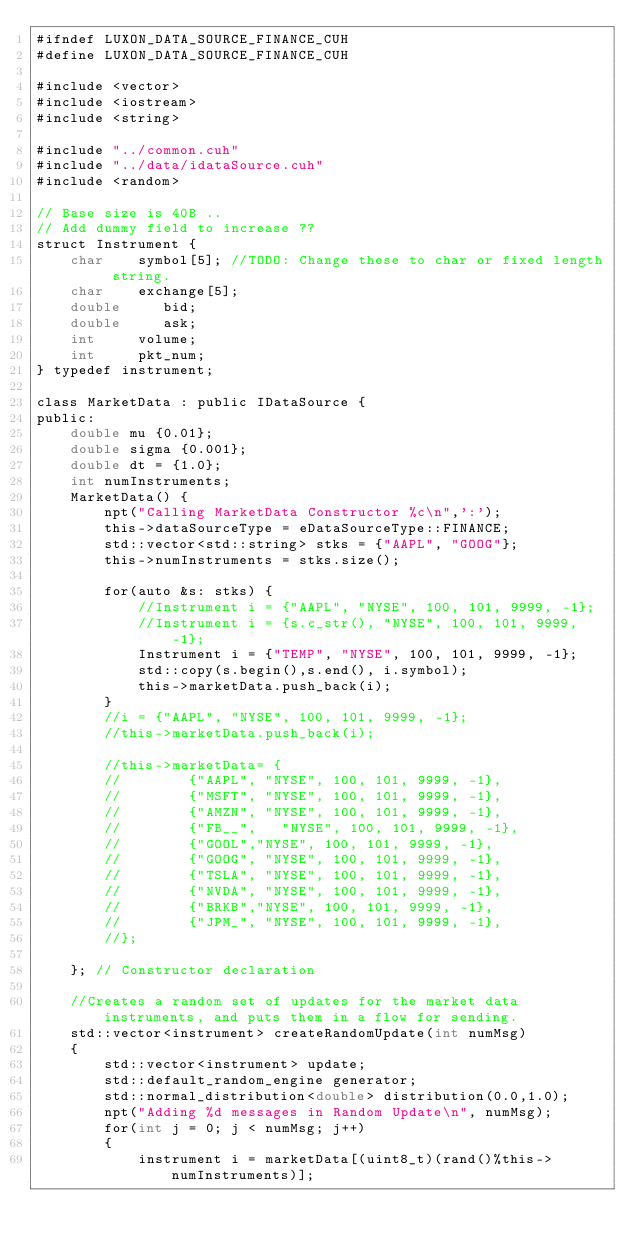<code> <loc_0><loc_0><loc_500><loc_500><_Cuda_>#ifndef LUXON_DATA_SOURCE_FINANCE_CUH
#define LUXON_DATA_SOURCE_FINANCE_CUH

#include <vector>
#include <iostream>
#include <string>

#include "../common.cuh"
#include "../data/idataSource.cuh"
#include <random>

// Base size is 40B ..
// Add dummy field to increase ?? 
struct Instrument {
    char    symbol[5]; //TODO: Change these to char or fixed length string.
    char    exchange[5];
    double     bid;
    double     ask;
    int     volume;
    int     pkt_num;
} typedef instrument;

class MarketData : public IDataSource {
public:
    double mu {0.01};
    double sigma {0.001};
    double dt = {1.0};
    int numInstruments;
    MarketData() {
        npt("Calling MarketData Constructor %c\n",':');
        this->dataSourceType = eDataSourceType::FINANCE;
        std::vector<std::string> stks = {"AAPL", "GOOG"};
        this->numInstruments = stks.size();

        for(auto &s: stks) {
            //Instrument i = {"AAPL", "NYSE", 100, 101, 9999, -1};
            //Instrument i = {s.c_str(), "NYSE", 100, 101, 9999, -1};
            Instrument i = {"TEMP", "NYSE", 100, 101, 9999, -1};
            std::copy(s.begin(),s.end(), i.symbol);
            this->marketData.push_back(i);
        }
        //i = {"AAPL", "NYSE", 100, 101, 9999, -1};
        //this->marketData.push_back(i);

        //this->marketData= {
        //        {"AAPL", "NYSE", 100, 101, 9999, -1},
        //        {"MSFT", "NYSE", 100, 101, 9999, -1},
        //        {"AMZN", "NYSE", 100, 101, 9999, -1},
        //        {"FB__",   "NYSE", 100, 101, 9999, -1},
        //        {"GOOL","NYSE", 100, 101, 9999, -1},
        //        {"GOOG", "NYSE", 100, 101, 9999, -1},
        //        {"TSLA", "NYSE", 100, 101, 9999, -1},
        //        {"NVDA", "NYSE", 100, 101, 9999, -1},
        //        {"BRKB","NYSE", 100, 101, 9999, -1},
        //        {"JPM_", "NYSE", 100, 101, 9999, -1},
        //};

    }; // Constructor declaration

    //Creates a random set of updates for the market data instruments, and puts them in a flow for sending.
    std::vector<instrument> createRandomUpdate(int numMsg)
    {
        std::vector<instrument> update;
        std::default_random_engine generator;
        std::normal_distribution<double> distribution(0.0,1.0);
        npt("Adding %d messages in Random Update\n", numMsg);
        for(int j = 0; j < numMsg; j++)
        {
            instrument i = marketData[(uint8_t)(rand()%this->numInstruments)];</code> 